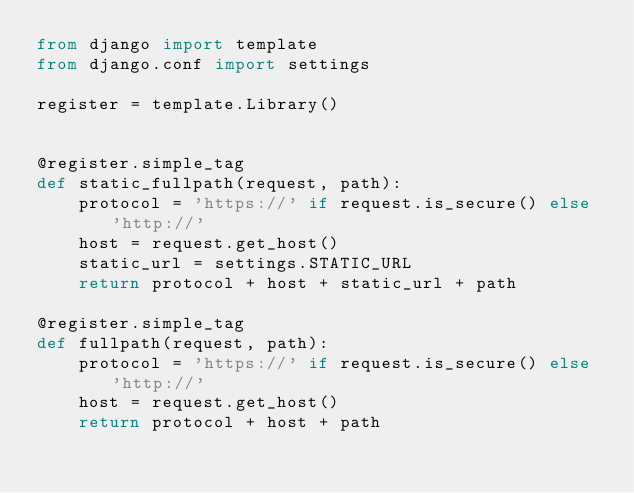<code> <loc_0><loc_0><loc_500><loc_500><_Python_>from django import template
from django.conf import settings

register = template.Library()


@register.simple_tag
def static_fullpath(request, path):
    protocol = 'https://' if request.is_secure() else 'http://'
    host = request.get_host()
    static_url = settings.STATIC_URL
    return protocol + host + static_url + path

@register.simple_tag
def fullpath(request, path):
    protocol = 'https://' if request.is_secure() else 'http://'
    host = request.get_host()
    return protocol + host + path</code> 